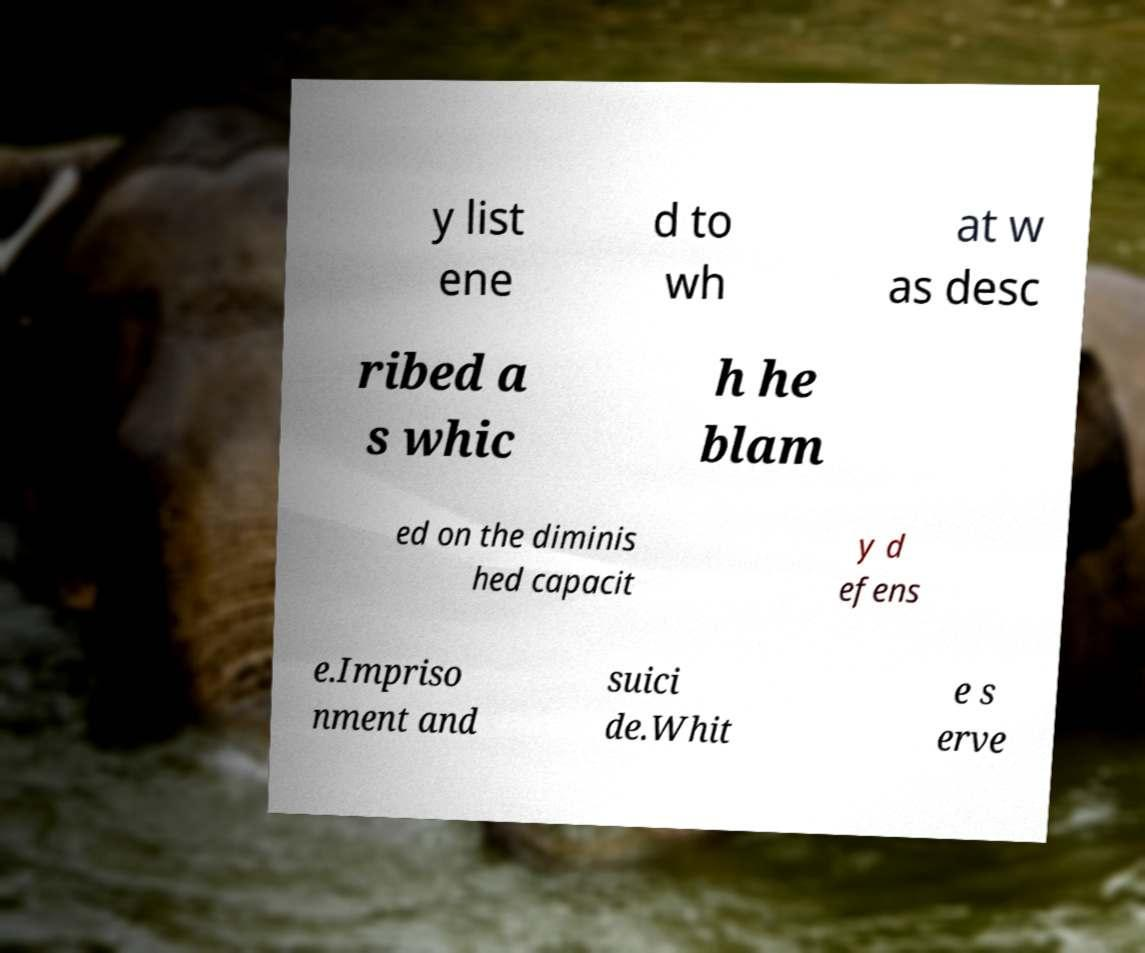Could you extract and type out the text from this image? y list ene d to wh at w as desc ribed a s whic h he blam ed on the diminis hed capacit y d efens e.Impriso nment and suici de.Whit e s erve 